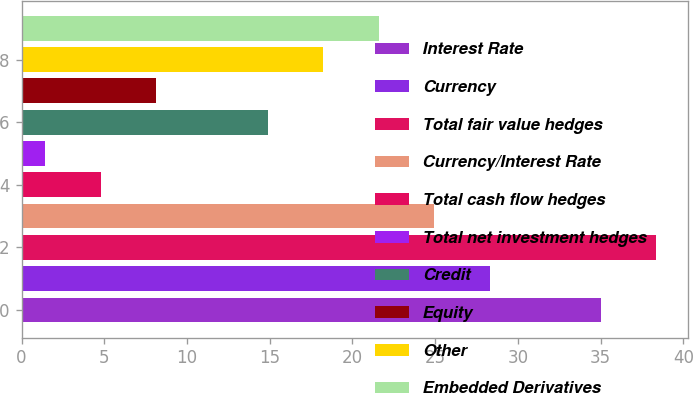Convert chart. <chart><loc_0><loc_0><loc_500><loc_500><bar_chart><fcel>Interest Rate<fcel>Currency<fcel>Total fair value hedges<fcel>Currency/Interest Rate<fcel>Total cash flow hedges<fcel>Total net investment hedges<fcel>Credit<fcel>Equity<fcel>Other<fcel>Embedded Derivatives<nl><fcel>35<fcel>28.31<fcel>38.36<fcel>24.95<fcel>4.79<fcel>1.43<fcel>14.87<fcel>8.15<fcel>18.23<fcel>21.59<nl></chart> 